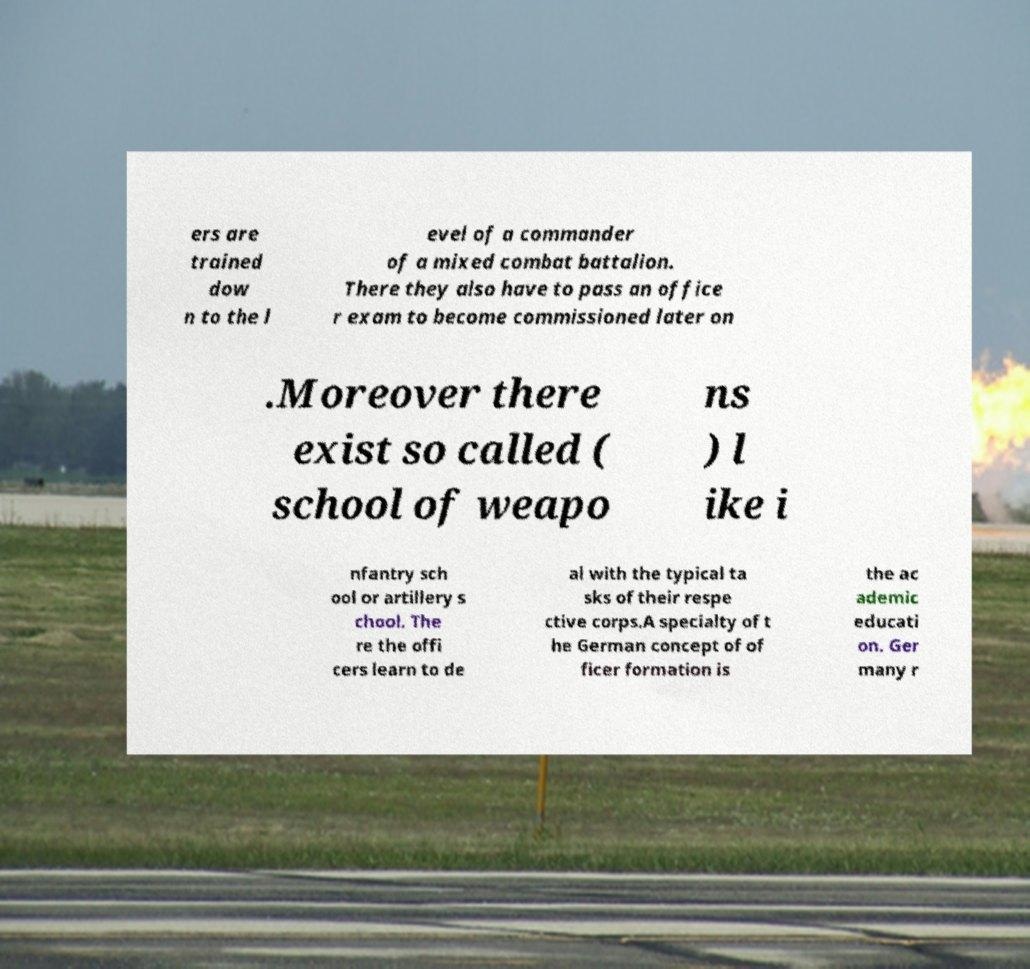Can you accurately transcribe the text from the provided image for me? ers are trained dow n to the l evel of a commander of a mixed combat battalion. There they also have to pass an office r exam to become commissioned later on .Moreover there exist so called ( school of weapo ns ) l ike i nfantry sch ool or artillery s chool. The re the offi cers learn to de al with the typical ta sks of their respe ctive corps.A specialty of t he German concept of of ficer formation is the ac ademic educati on. Ger many r 